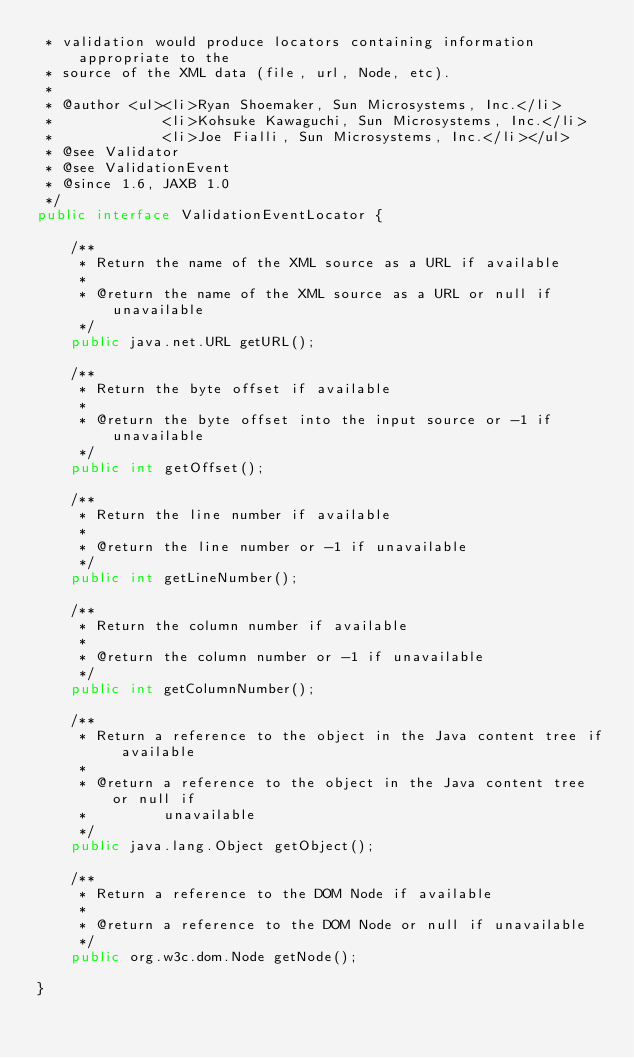<code> <loc_0><loc_0><loc_500><loc_500><_Java_> * validation would produce locators containing information appropriate to the 
 * source of the XML data (file, url, Node, etc).
 *
 * @author <ul><li>Ryan Shoemaker, Sun Microsystems, Inc.</li>
 *             <li>Kohsuke Kawaguchi, Sun Microsystems, Inc.</li>
 *             <li>Joe Fialli, Sun Microsystems, Inc.</li></ul>
 * @see Validator
 * @see ValidationEvent
 * @since 1.6, JAXB 1.0
 */
public interface ValidationEventLocator {

    /**
     * Return the name of the XML source as a URL if available
     *
     * @return the name of the XML source as a URL or null if unavailable
     */
    public java.net.URL getURL();
    
    /**
     * Return the byte offset if available
     *
     * @return the byte offset into the input source or -1 if unavailable
     */
    public int getOffset();
    
    /**
     * Return the line number if available
     *
     * @return the line number or -1 if unavailable 
     */
    public int getLineNumber();
    
    /**
     * Return the column number if available
     *
     * @return the column number or -1 if unavailable
     */
    public int getColumnNumber();
    
    /**
     * Return a reference to the object in the Java content tree if available
     *
     * @return a reference to the object in the Java content tree or null if
     *         unavailable
     */
    public java.lang.Object getObject();
    
    /**
     * Return a reference to the DOM Node if available
     *
     * @return a reference to the DOM Node or null if unavailable 
     */
    public org.w3c.dom.Node getNode();
    
}
</code> 